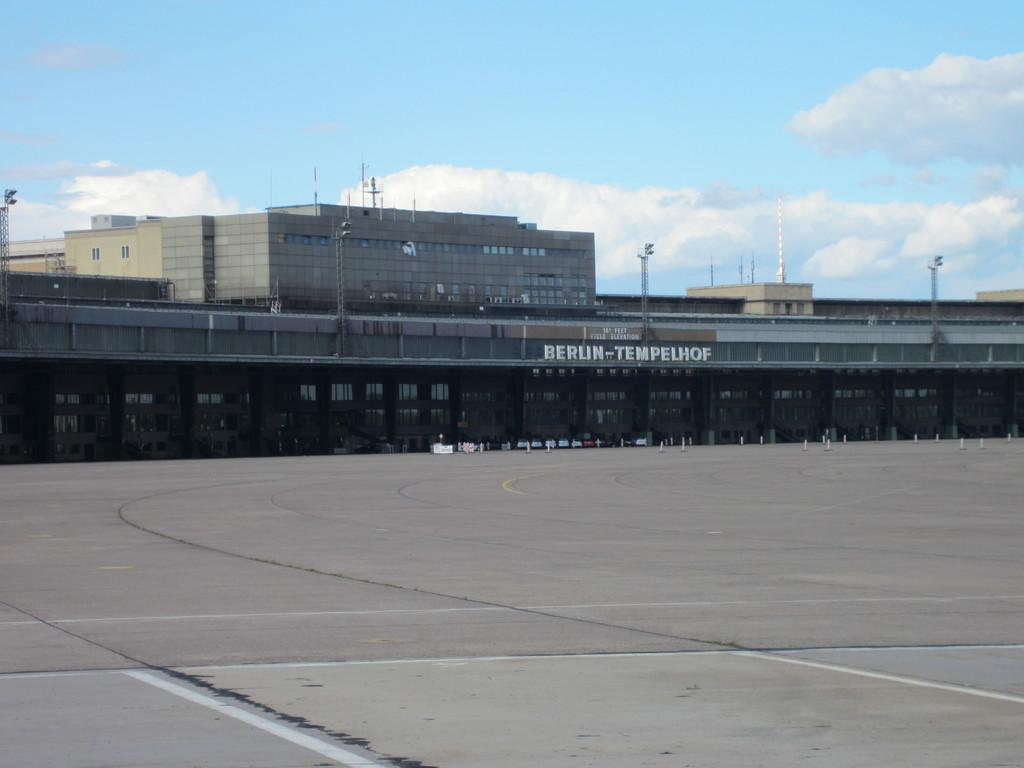What is the main subject of the image? The image depicts a road. What can be seen alongside the road? There are buildings, boards, and poles visible along the road. What is visible in the background of the image? The sky is visible in the background of the image. What is the condition of the sky in the image? Clouds are present in the sky. What type of sack can be seen flying through the air in the image? There is no sack or any object flying through the air in the image; it depicts a road with buildings, boards, and poles, and a sky with clouds. What is the purpose of the road in the image? The image does not provide information about the purpose of the road; it only shows its appearance and the surrounding elements. 